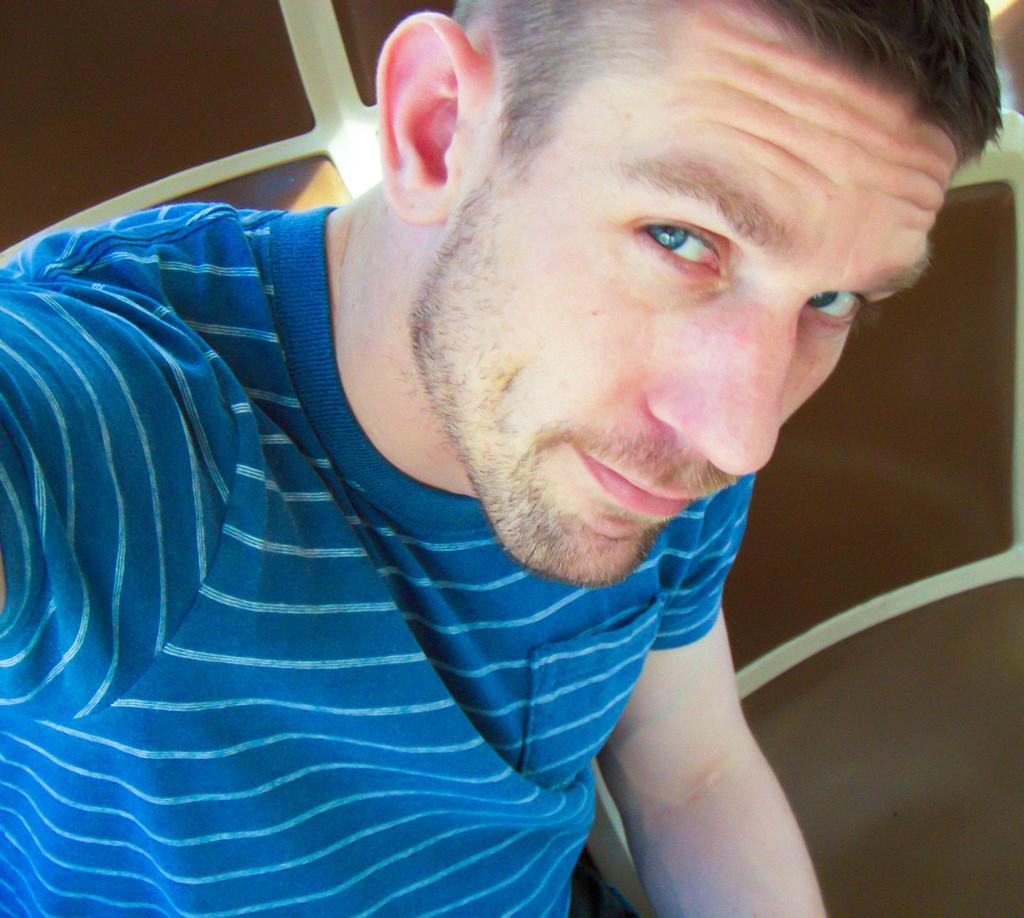In one or two sentences, can you explain what this image depicts? This picture shows a man seated in the chair and he wore a blue color t-shirt and we see a another chair on the side. 